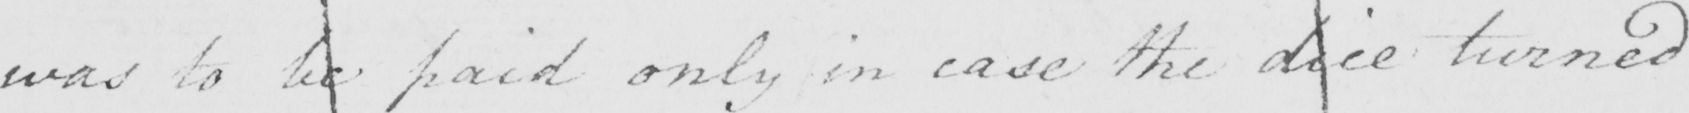Please transcribe the handwritten text in this image. was to be paid only in case the dice turned 